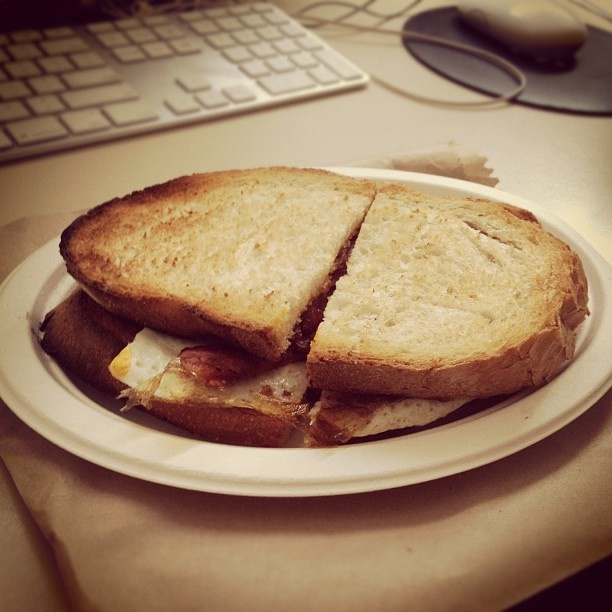Describe the objects in this image and their specific colors. I can see sandwich in black, maroon, and tan tones, keyboard in black, tan, gray, and maroon tones, and mouse in black, tan, maroon, and gray tones in this image. 